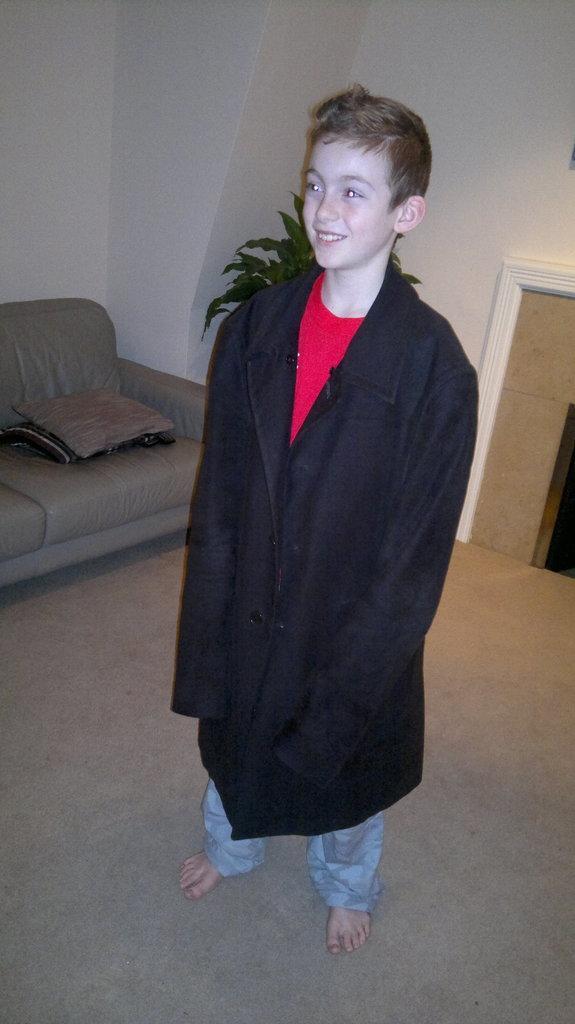In one or two sentences, can you explain what this image depicts? In this image I can see a boy standing, wearing a oversized black coat. There is a couch on the left. There is a plant at the back. There are white wall. 